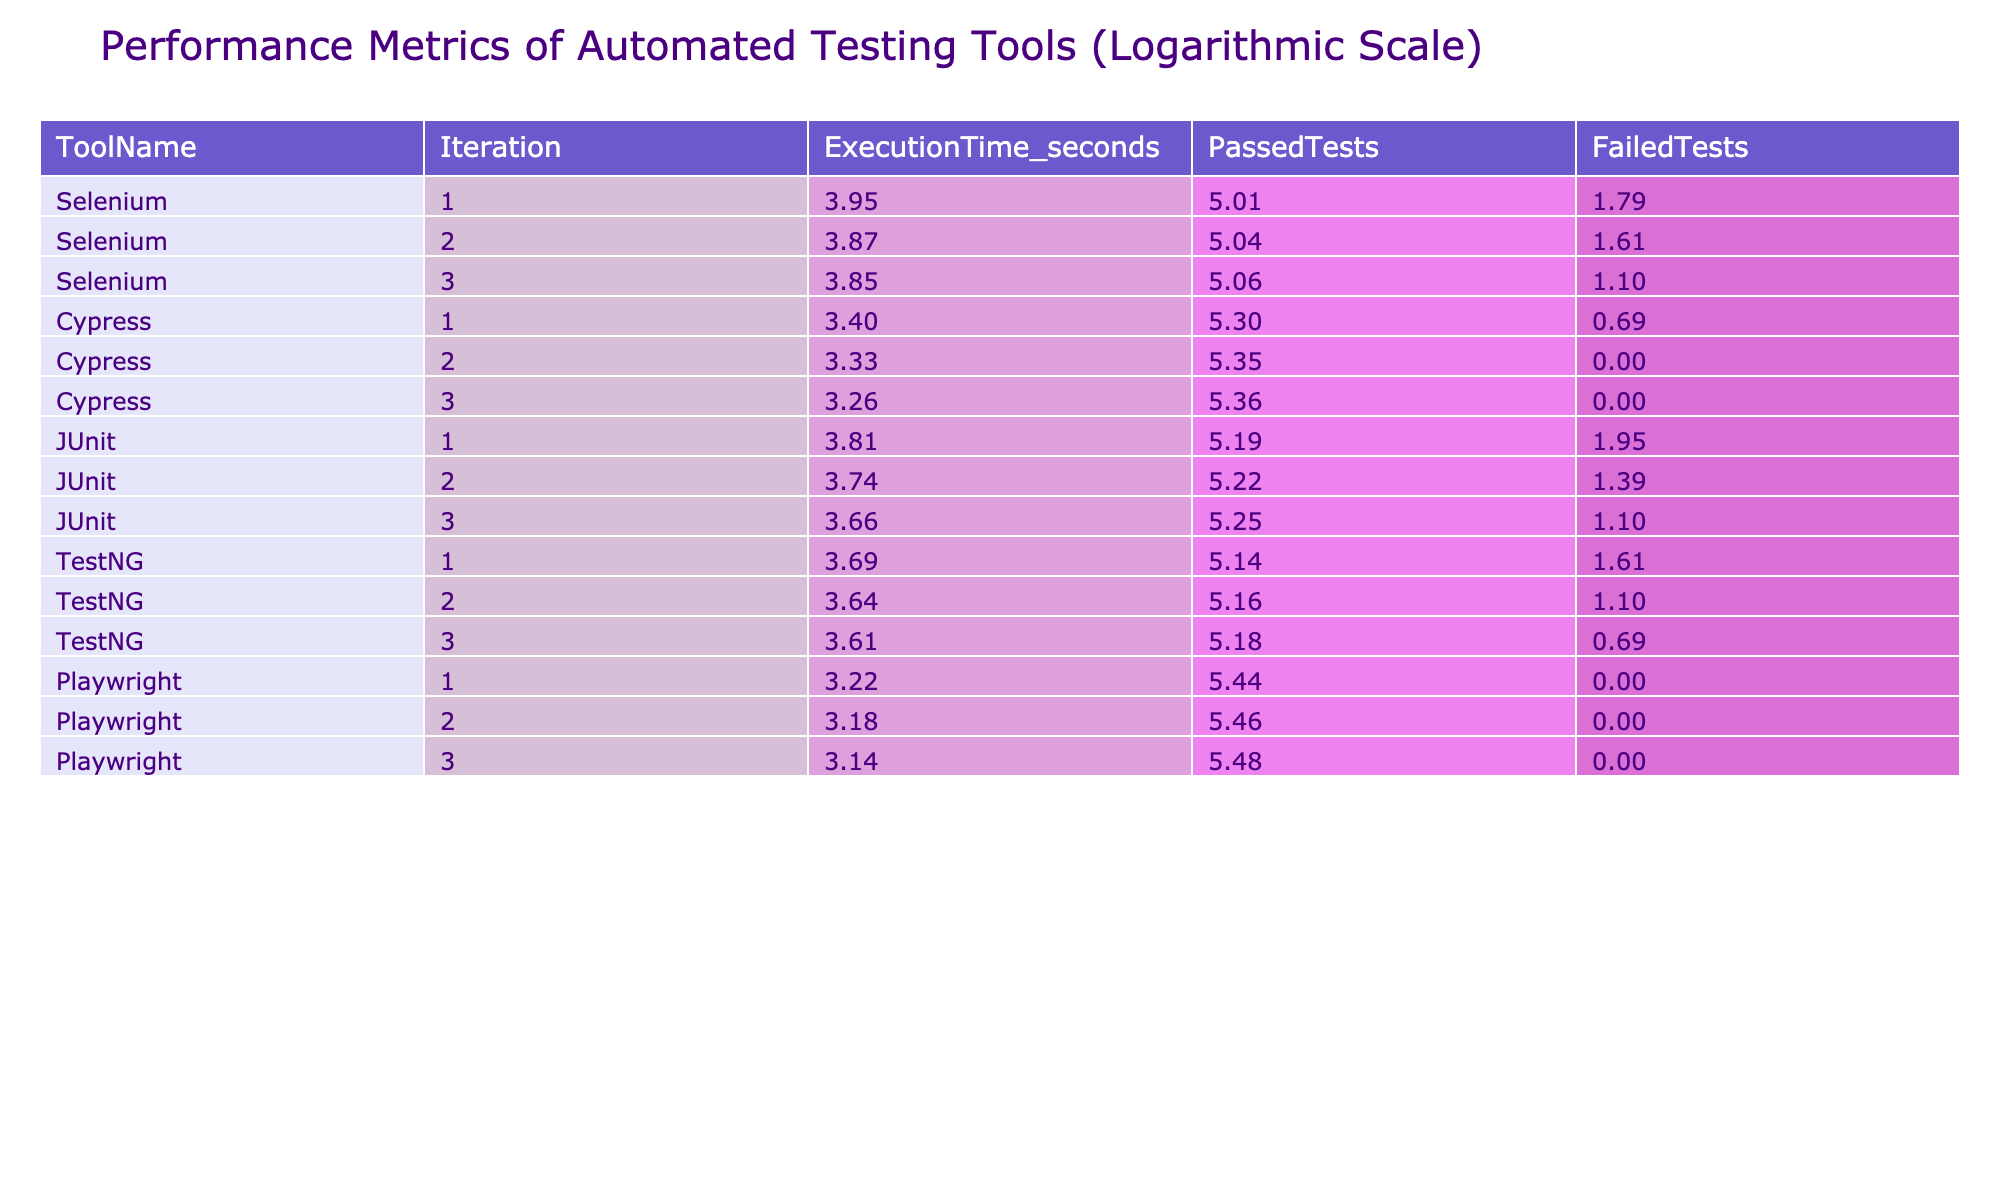What is the execution time of Cypress in the third iteration? Looking at the table, I can find the row for Cypress in iteration 3. The execution time is listed directly under the "ExecutionTime_seconds" column, which shows 26 seconds for this iteration.
Answer: 26 Which tool had the highest number of passed tests in the first iteration? In the first iteration, I can compare the "PassedTests" column for each tool. Cypress has 200 passed tests, which is the highest when compared to the other tools.
Answer: Cypress What is the total number of failed tests across all iterations for Selenium? To find the total failed tests for Selenium, I look at the "FailedTests" column for all its iterations: 5, 4, and 2. Summing these values gives 5 + 4 + 2 = 11.
Answer: 11 Was there any tool that had a failed test count of zero in the third iteration? I check the "FailedTests" column for the third iteration of each tool. Both Cypress and Playwright have zero failed tests, thus confirming that yes, there were tools with no failed tests in that iteration.
Answer: Yes What is the average execution time of the tools in the second iteration? I first extract the execution times for the second iteration: 48 (Selenium), 28 (Cypress), 42 (JUnit), 38 (TestNG), and 24 (Playwright). The sum is 48 + 28 + 42 + 38 + 24 = 180. Since there are 5 tools, the average is 180 divided by 5, which equals 36.
Answer: 36 Which tool consistently had the lowest execution time across all iterations? I examine the execution times for each tool across all iterations: Selenium (52, 48, 47), Cypress (30, 28, 26), JUnit (45, 42, 39), TestNG (40, 38, 37), and Playwright (25, 24, 23). Playwright consistently has the lowest values of 25, 24, and 23 across all iterations.
Answer: Playwright What is the percentage of passed tests for JUnit in the first iteration? For JUnit in the first iteration, the number of passed tests is 180 out of a total of 186 tests (180 passed + 6 failed). To find the percentage, I compute (180 / 186) * 100, which equals approximately 96.77%.
Answer: 96.77% Do all the tools have a decreasing trend in execution time over the iterations? By analyzing the execution times: Selenium (52, 48, 47) decreases; Cypress (30, 28, 26) decreases; JUnit (45, 42, 39) decreases; TestNG (40, 38, 37) decreases; Playwright (25, 24, 23) decreases as well. Thus, I can conclude that all tools exhibit a decreasing trend in their execution times across iterations.
Answer: Yes 